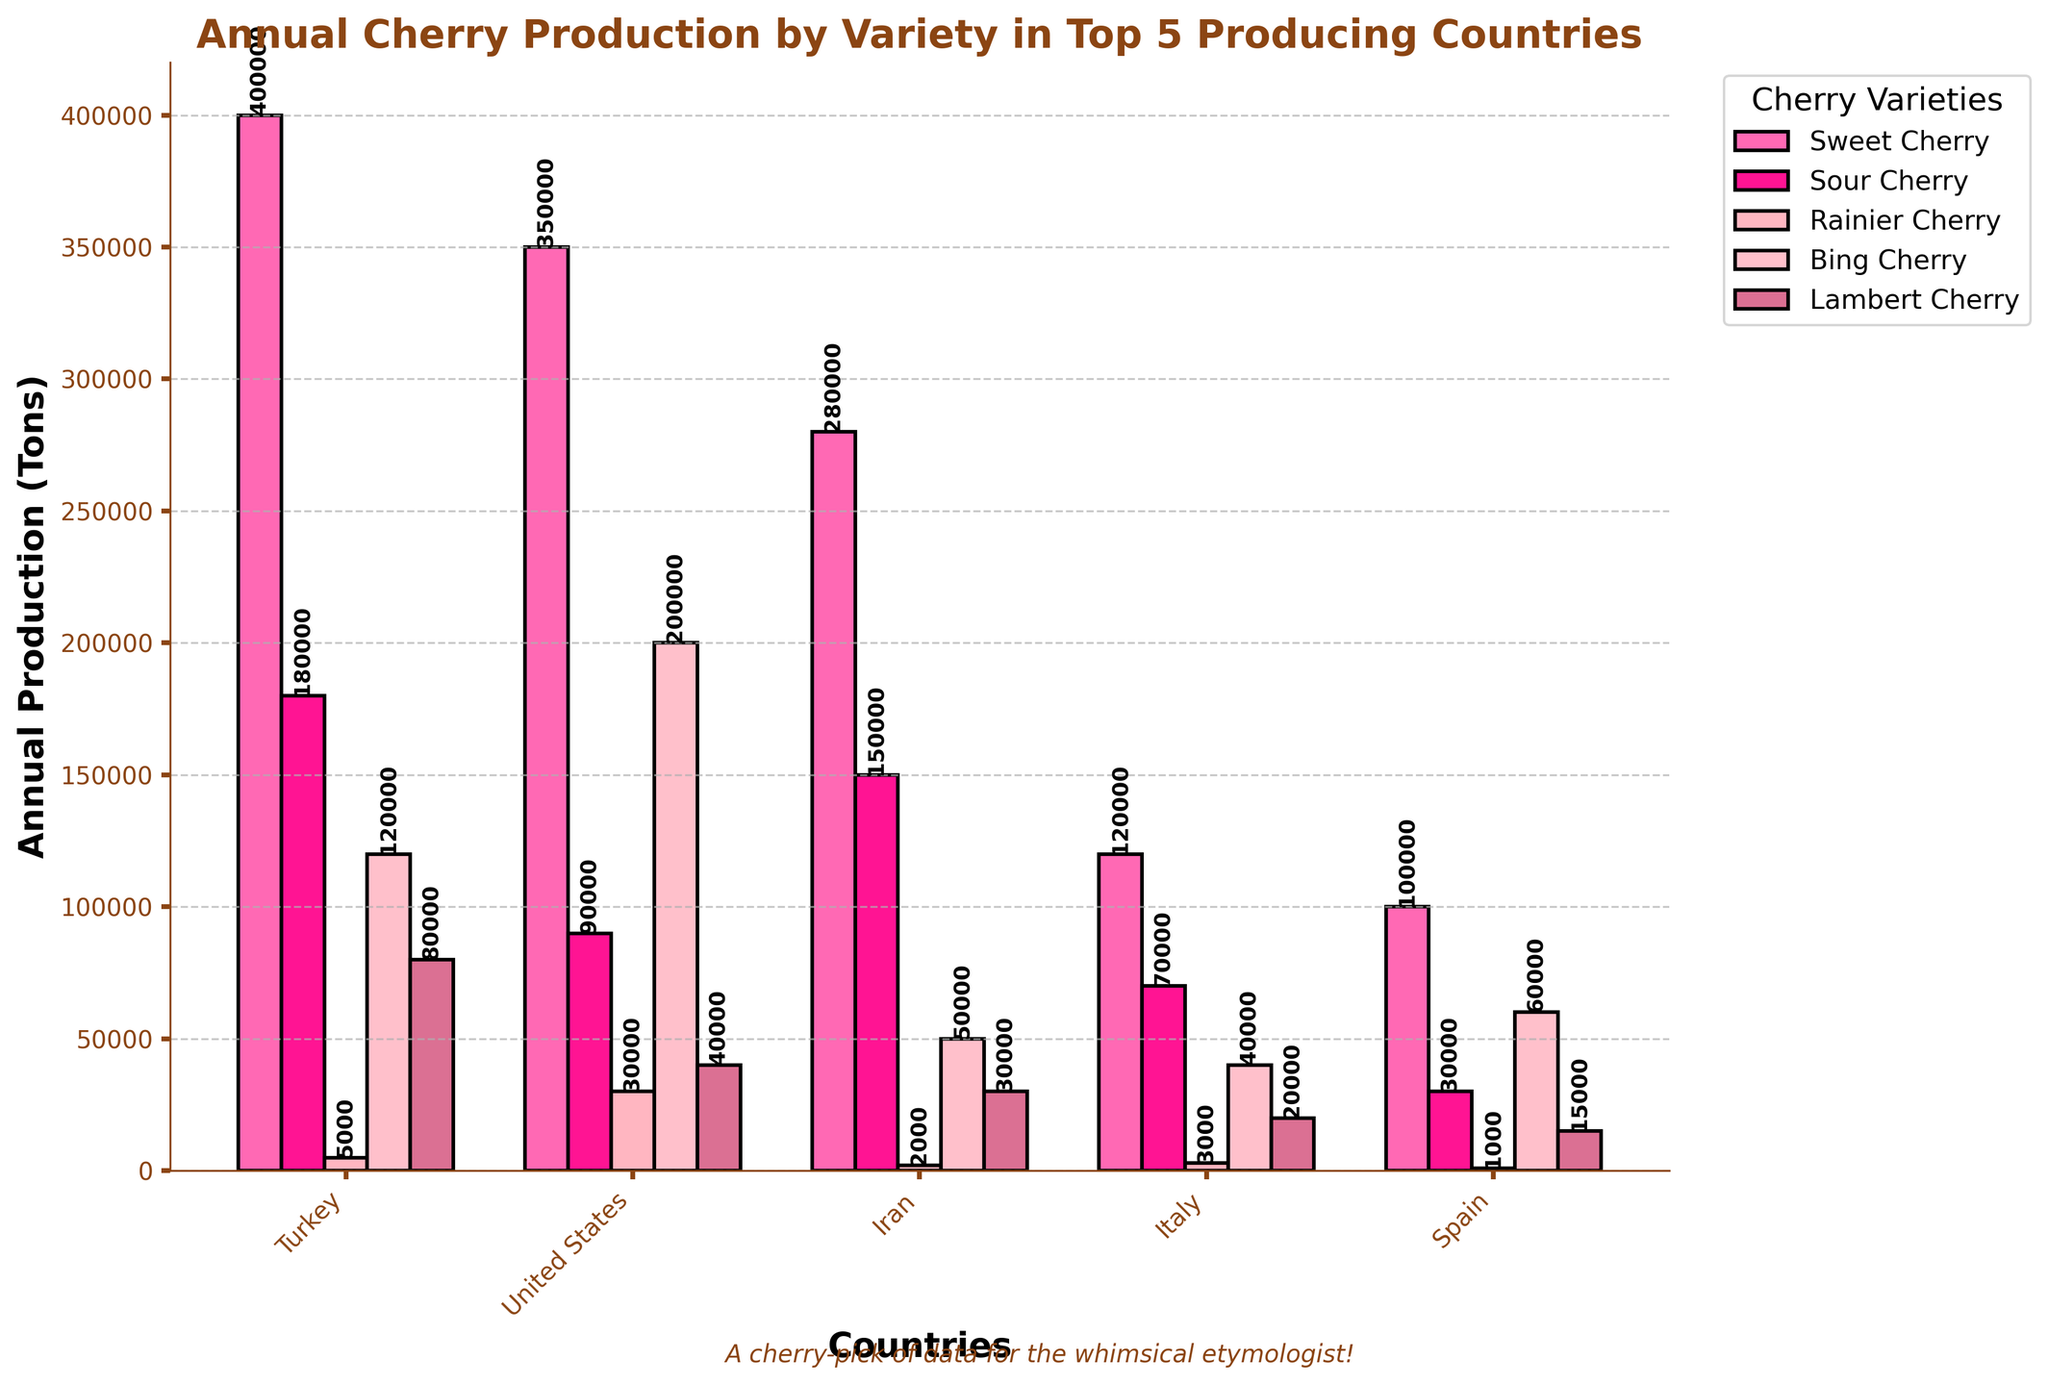Which country produces the most Sweet Cherries? To find the country that produces the most Sweet Cherries, look at the heights of the bars labeled "Sweet Cherry" for each country. The tallest bar in this category is for Turkey.
Answer: Turkey Which country produces more Rainier Cherries: Spain or Iran? Compare the heights of the bars labeled "Rainier Cherry" for Spain and Iran. Iran's bar is taller than Spain's, indicating Iran produces more.
Answer: Iran What is the total annual production of Sour Cherries for Italy and Spain combined? Add the values for Sour Cherry production in Italy (70,000) and Spain (30,000). 70,000 + 30,000 = 100,000.
Answer: 100,000 By how much does the Bing Cherry production of the United States exceed that of Italy? Subtract Italy's Bing Cherry production (40,000) from the United States' Bing Cherry production (200,000). 200,000 - 40,000 = 160,000.
Answer: 160,000 What is the average annual production of Lambert Cherry across the top 5 producing countries? Add the Lambert Cherry production values for all countries (80,000 + 40,000 + 30,000 + 20,000 + 15,000) and then divide by 5. (80,000 + 40,000 + 30,000 + 20,000 + 15,000) / 5 = 185,000 / 5 = 37,000.
Answer: 37,000 Which cherry variety has the least production in Turkey? Look at the bar heights for each cherry variety in Turkey and identify the shortest one. The shortest bar is for "Rainier Cherry".
Answer: Rainier Cherry What's the difference in total cherry production (all varieties combined) between Turkey and the United States? Sum the production values for all varieties in Turkey and the United States, then subtract the total for the United States from Turkey. Turkey's total: 400,000 + 180,000 + 5,000 + 120,000 + 80,000 = 785,000. United States' total: 350,000 + 90,000 + 30,000 + 200,000 + 40,000 = 710,000. Difference: 785,000 - 710,000 = 75,000.
Answer: 75,000 Which country produces the most Sour Cherries? Look at the height of the bars labeled "Sour Cherry" for each country. The tallest bar is for Turkey.
Answer: Turkey 